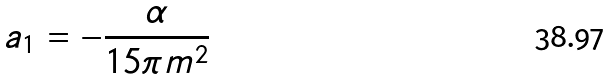Convert formula to latex. <formula><loc_0><loc_0><loc_500><loc_500>a _ { 1 } = - \frac { \alpha } { 1 5 \pi m ^ { 2 } }</formula> 